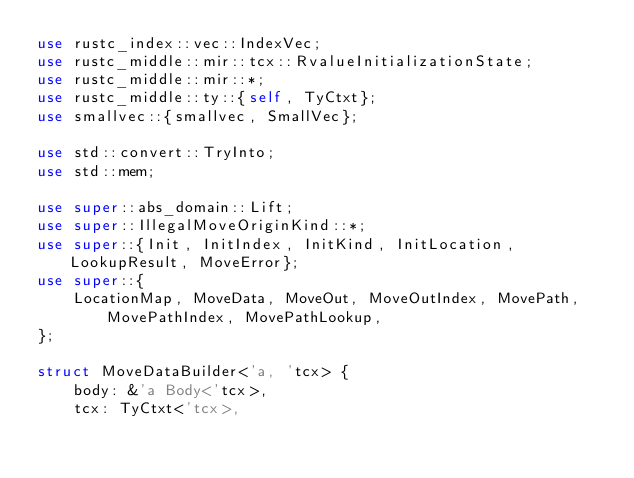Convert code to text. <code><loc_0><loc_0><loc_500><loc_500><_Rust_>use rustc_index::vec::IndexVec;
use rustc_middle::mir::tcx::RvalueInitializationState;
use rustc_middle::mir::*;
use rustc_middle::ty::{self, TyCtxt};
use smallvec::{smallvec, SmallVec};

use std::convert::TryInto;
use std::mem;

use super::abs_domain::Lift;
use super::IllegalMoveOriginKind::*;
use super::{Init, InitIndex, InitKind, InitLocation, LookupResult, MoveError};
use super::{
    LocationMap, MoveData, MoveOut, MoveOutIndex, MovePath, MovePathIndex, MovePathLookup,
};

struct MoveDataBuilder<'a, 'tcx> {
    body: &'a Body<'tcx>,
    tcx: TyCtxt<'tcx>,</code> 